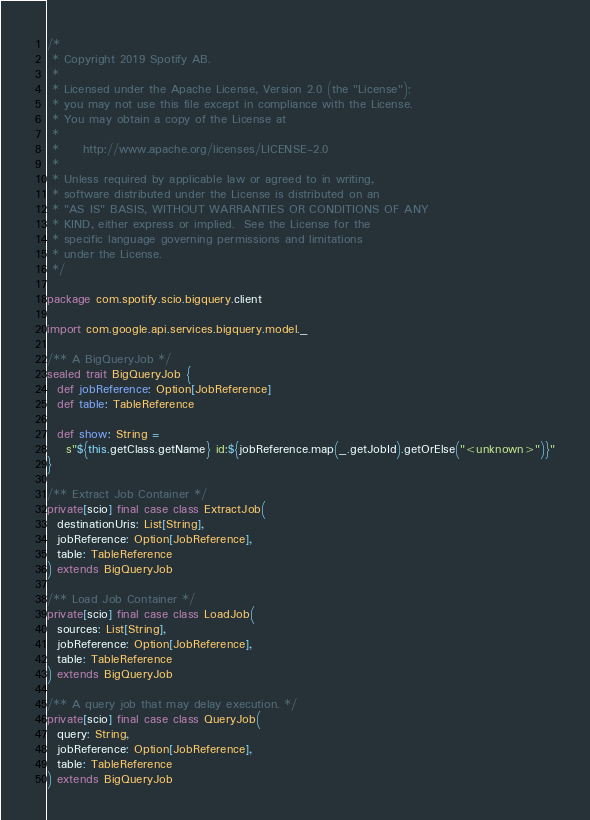Convert code to text. <code><loc_0><loc_0><loc_500><loc_500><_Scala_>/*
 * Copyright 2019 Spotify AB.
 *
 * Licensed under the Apache License, Version 2.0 (the "License");
 * you may not use this file except in compliance with the License.
 * You may obtain a copy of the License at
 *
 *     http://www.apache.org/licenses/LICENSE-2.0
 *
 * Unless required by applicable law or agreed to in writing,
 * software distributed under the License is distributed on an
 * "AS IS" BASIS, WITHOUT WARRANTIES OR CONDITIONS OF ANY
 * KIND, either express or implied.  See the License for the
 * specific language governing permissions and limitations
 * under the License.
 */

package com.spotify.scio.bigquery.client

import com.google.api.services.bigquery.model._

/** A BigQueryJob */
sealed trait BigQueryJob {
  def jobReference: Option[JobReference]
  def table: TableReference

  def show: String =
    s"${this.getClass.getName} id:${jobReference.map(_.getJobId).getOrElse("<unknown>")}"
}

/** Extract Job Container */
private[scio] final case class ExtractJob(
  destinationUris: List[String],
  jobReference: Option[JobReference],
  table: TableReference
) extends BigQueryJob

/** Load Job Container */
private[scio] final case class LoadJob(
  sources: List[String],
  jobReference: Option[JobReference],
  table: TableReference
) extends BigQueryJob

/** A query job that may delay execution. */
private[scio] final case class QueryJob(
  query: String,
  jobReference: Option[JobReference],
  table: TableReference
) extends BigQueryJob
</code> 